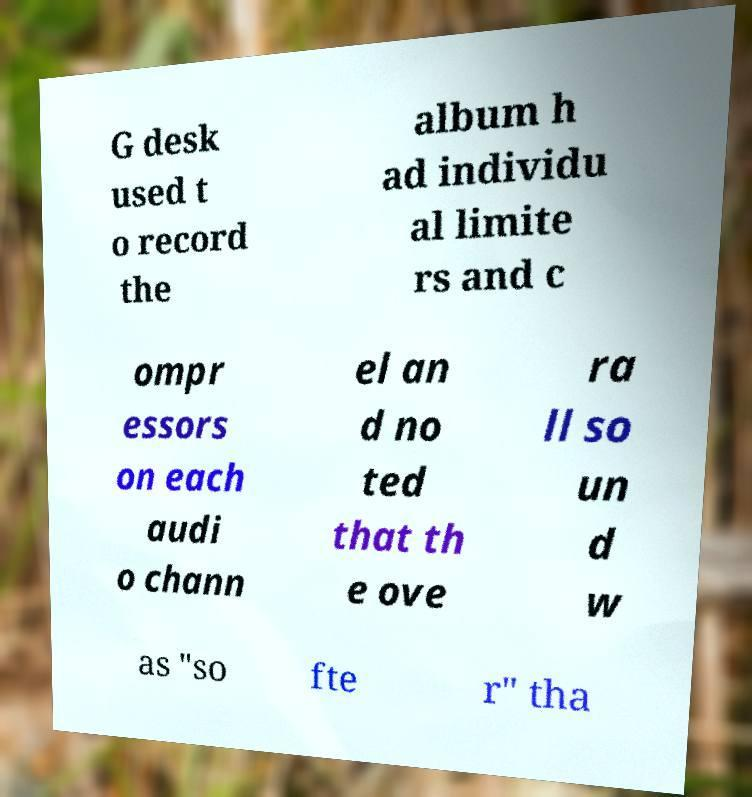What messages or text are displayed in this image? I need them in a readable, typed format. G desk used t o record the album h ad individu al limite rs and c ompr essors on each audi o chann el an d no ted that th e ove ra ll so un d w as "so fte r" tha 